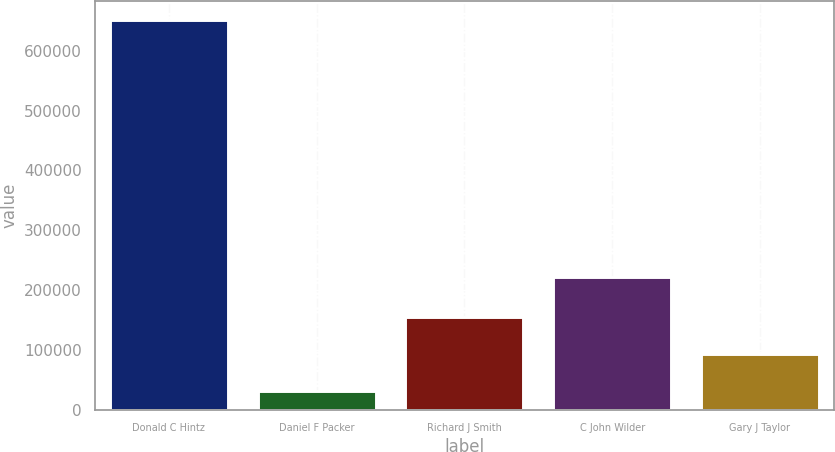Convert chart to OTSL. <chart><loc_0><loc_0><loc_500><loc_500><bar_chart><fcel>Donald C Hintz<fcel>Daniel F Packer<fcel>Richard J Smith<fcel>C John Wilder<fcel>Gary J Taylor<nl><fcel>650920<fcel>30799<fcel>154823<fcel>222430<fcel>92811.1<nl></chart> 